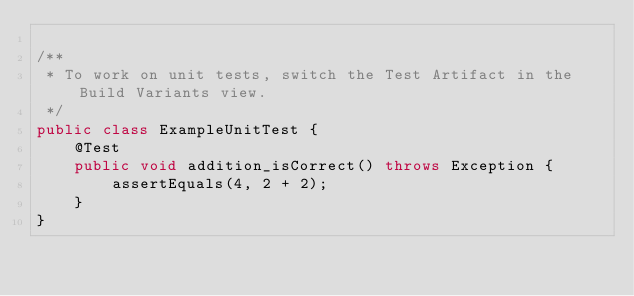Convert code to text. <code><loc_0><loc_0><loc_500><loc_500><_Java_>
/**
 * To work on unit tests, switch the Test Artifact in the Build Variants view.
 */
public class ExampleUnitTest {
    @Test
    public void addition_isCorrect() throws Exception {
        assertEquals(4, 2 + 2);
    }
}</code> 